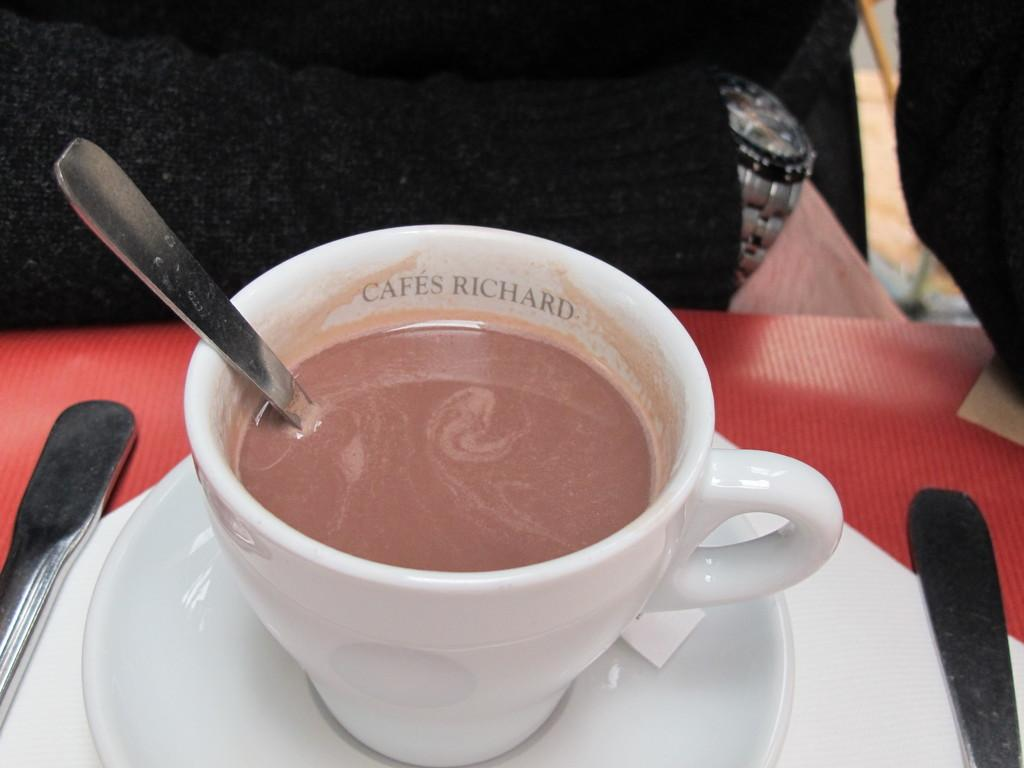What object is located in the foreground of the image? There is a cup in the foreground of the image. What is placed on the saucer in the foreground? A spoon is placed on a saucer in the foreground. What is the saucer placed on in the foreground? The saucer is placed on a tissue in the foreground. Can you describe the objects visible in the background of the image? There are spoons visible in the background of the image, and there is a person wearing a wrist watch. Can you tell me how many beetles are crawling on the wrist watch in the image? There are no beetles present in the image; the person is wearing a wrist watch, but there are no beetles visible. What type of balance is being used by the person in the image? There is no indication of any balance being used in the image; the person is simply wearing a wrist watch. 